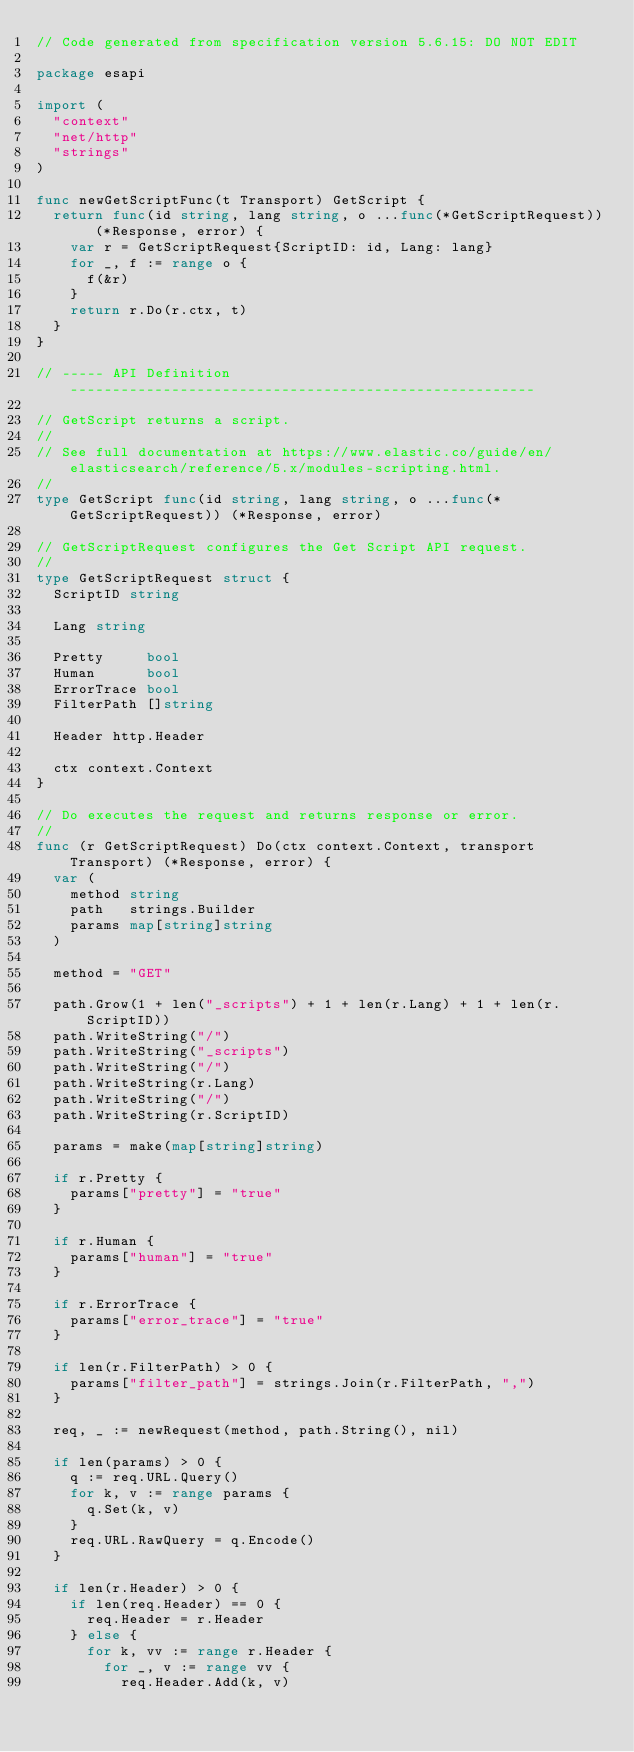Convert code to text. <code><loc_0><loc_0><loc_500><loc_500><_Go_>// Code generated from specification version 5.6.15: DO NOT EDIT

package esapi

import (
	"context"
	"net/http"
	"strings"
)

func newGetScriptFunc(t Transport) GetScript {
	return func(id string, lang string, o ...func(*GetScriptRequest)) (*Response, error) {
		var r = GetScriptRequest{ScriptID: id, Lang: lang}
		for _, f := range o {
			f(&r)
		}
		return r.Do(r.ctx, t)
	}
}

// ----- API Definition -------------------------------------------------------

// GetScript returns a script.
//
// See full documentation at https://www.elastic.co/guide/en/elasticsearch/reference/5.x/modules-scripting.html.
//
type GetScript func(id string, lang string, o ...func(*GetScriptRequest)) (*Response, error)

// GetScriptRequest configures the Get Script API request.
//
type GetScriptRequest struct {
	ScriptID string

	Lang string

	Pretty     bool
	Human      bool
	ErrorTrace bool
	FilterPath []string

	Header http.Header

	ctx context.Context
}

// Do executes the request and returns response or error.
//
func (r GetScriptRequest) Do(ctx context.Context, transport Transport) (*Response, error) {
	var (
		method string
		path   strings.Builder
		params map[string]string
	)

	method = "GET"

	path.Grow(1 + len("_scripts") + 1 + len(r.Lang) + 1 + len(r.ScriptID))
	path.WriteString("/")
	path.WriteString("_scripts")
	path.WriteString("/")
	path.WriteString(r.Lang)
	path.WriteString("/")
	path.WriteString(r.ScriptID)

	params = make(map[string]string)

	if r.Pretty {
		params["pretty"] = "true"
	}

	if r.Human {
		params["human"] = "true"
	}

	if r.ErrorTrace {
		params["error_trace"] = "true"
	}

	if len(r.FilterPath) > 0 {
		params["filter_path"] = strings.Join(r.FilterPath, ",")
	}

	req, _ := newRequest(method, path.String(), nil)

	if len(params) > 0 {
		q := req.URL.Query()
		for k, v := range params {
			q.Set(k, v)
		}
		req.URL.RawQuery = q.Encode()
	}

	if len(r.Header) > 0 {
		if len(req.Header) == 0 {
			req.Header = r.Header
		} else {
			for k, vv := range r.Header {
				for _, v := range vv {
					req.Header.Add(k, v)</code> 